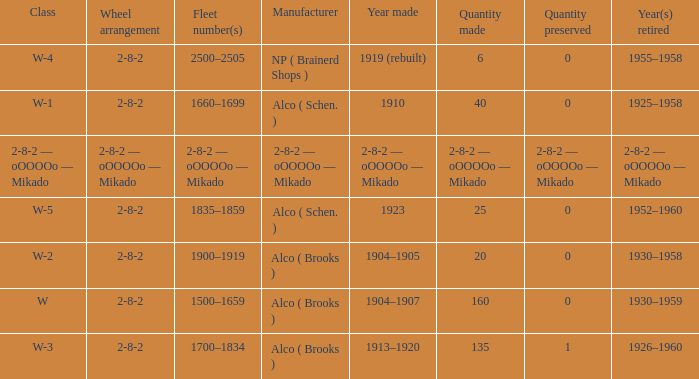Parse the table in full. {'header': ['Class', 'Wheel arrangement', 'Fleet number(s)', 'Manufacturer', 'Year made', 'Quantity made', 'Quantity preserved', 'Year(s) retired'], 'rows': [['W-4', '2-8-2', '2500–2505', 'NP ( Brainerd Shops )', '1919 (rebuilt)', '6', '0', '1955–1958'], ['W-1', '2-8-2', '1660–1699', 'Alco ( Schen. )', '1910', '40', '0', '1925–1958'], ['2-8-2 — oOOOOo — Mikado', '2-8-2 — oOOOOo — Mikado', '2-8-2 — oOOOOo — Mikado', '2-8-2 — oOOOOo — Mikado', '2-8-2 — oOOOOo — Mikado', '2-8-2 — oOOOOo — Mikado', '2-8-2 — oOOOOo — Mikado', '2-8-2 — oOOOOo — Mikado'], ['W-5', '2-8-2', '1835–1859', 'Alco ( Schen. )', '1923', '25', '0', '1952–1960'], ['W-2', '2-8-2', '1900–1919', 'Alco ( Brooks )', '1904–1905', '20', '0', '1930–1958'], ['W', '2-8-2', '1500–1659', 'Alco ( Brooks )', '1904–1907', '160', '0', '1930–1959'], ['W-3', '2-8-2', '1700–1834', 'Alco ( Brooks )', '1913–1920', '135', '1', '1926–1960']]} Which class had a quantity made of 20? W-2. 